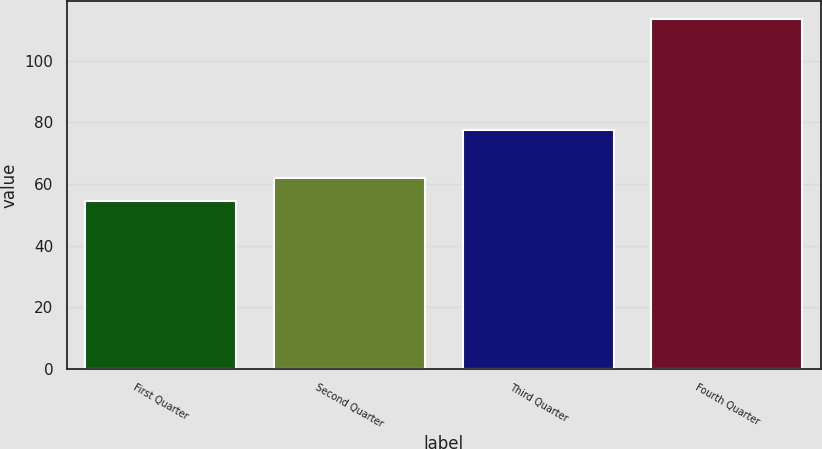<chart> <loc_0><loc_0><loc_500><loc_500><bar_chart><fcel>First Quarter<fcel>Second Quarter<fcel>Third Quarter<fcel>Fourth Quarter<nl><fcel>54.61<fcel>61.94<fcel>77.51<fcel>113.51<nl></chart> 